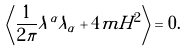Convert formula to latex. <formula><loc_0><loc_0><loc_500><loc_500>\left \langle \frac { 1 } { 2 \pi } \lambda ^ { \alpha } \lambda _ { \alpha } + 4 m H ^ { 2 } \right \rangle = 0 .</formula> 